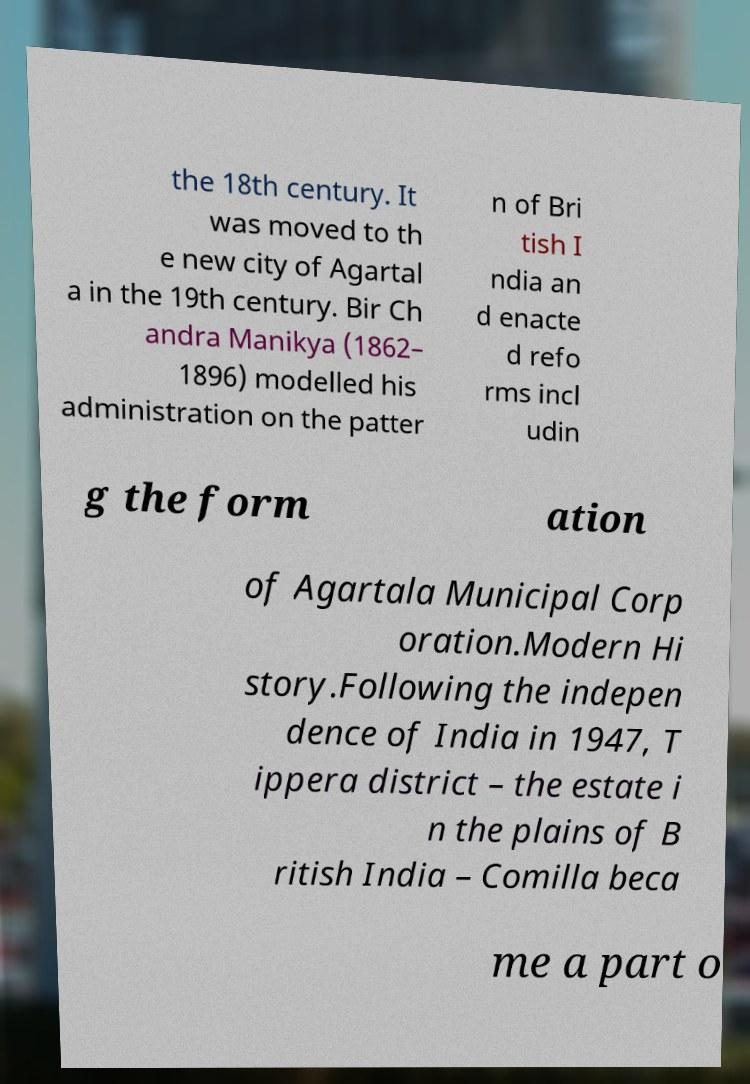Please identify and transcribe the text found in this image. the 18th century. It was moved to th e new city of Agartal a in the 19th century. Bir Ch andra Manikya (1862– 1896) modelled his administration on the patter n of Bri tish I ndia an d enacte d refo rms incl udin g the form ation of Agartala Municipal Corp oration.Modern Hi story.Following the indepen dence of India in 1947, T ippera district – the estate i n the plains of B ritish India – Comilla beca me a part o 